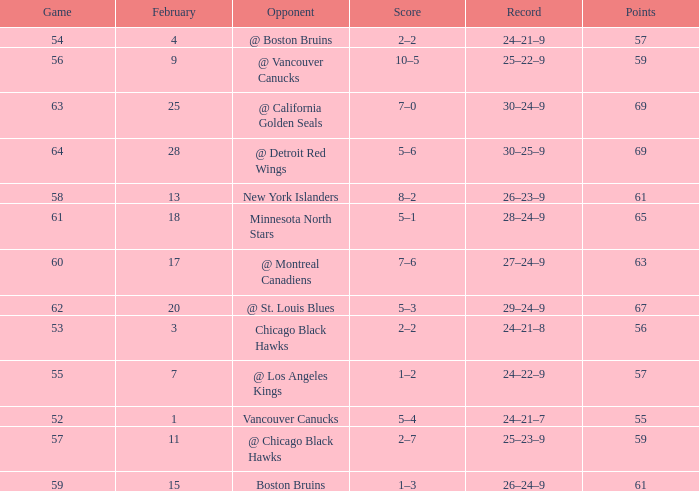How many february games had a record of 29–24–9? 20.0. 